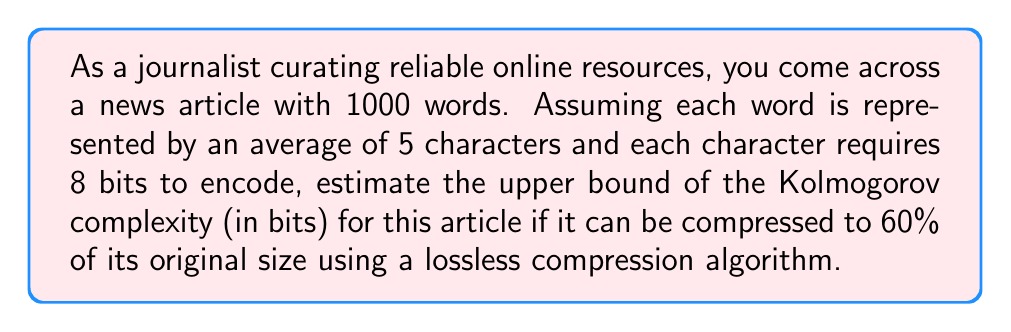Show me your answer to this math problem. To solve this problem, we need to follow these steps:

1. Calculate the original size of the article in bits:
   - Number of words: 1000
   - Average characters per word: 5
   - Bits per character: 8
   - Total bits = $1000 \times 5 \times 8 = 40,000$ bits

2. Calculate the compressed size:
   - Compression ratio: 60%
   - Compressed size = $40,000 \times 0.60 = 24,000$ bits

3. Estimate the upper bound of Kolmogorov complexity:
   The Kolmogorov complexity is the length of the shortest program that can produce the given string. In this case, we can use the compressed size as an upper bound for the Kolmogorov complexity. This is because the compression algorithm provides a way to represent the article in fewer bits, and the Kolmogorov complexity cannot be larger than this compressed representation.

   Therefore, the upper bound of the Kolmogorov complexity is 24,000 bits.

It's important to note that this is an upper bound estimate. The actual Kolmogorov complexity could be lower if there exists an even more efficient way to represent the article's information content.
Answer: The estimated upper bound of the Kolmogorov complexity for the news article is 24,000 bits. 